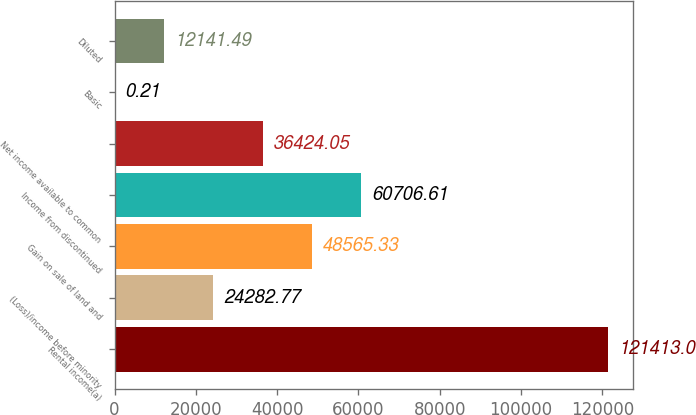<chart> <loc_0><loc_0><loc_500><loc_500><bar_chart><fcel>Rental income(a)<fcel>(Loss)/income before minority<fcel>Gain on sale of land and<fcel>Income from discontinued<fcel>Net income available to common<fcel>Basic<fcel>Diluted<nl><fcel>121413<fcel>24282.8<fcel>48565.3<fcel>60706.6<fcel>36424.1<fcel>0.21<fcel>12141.5<nl></chart> 